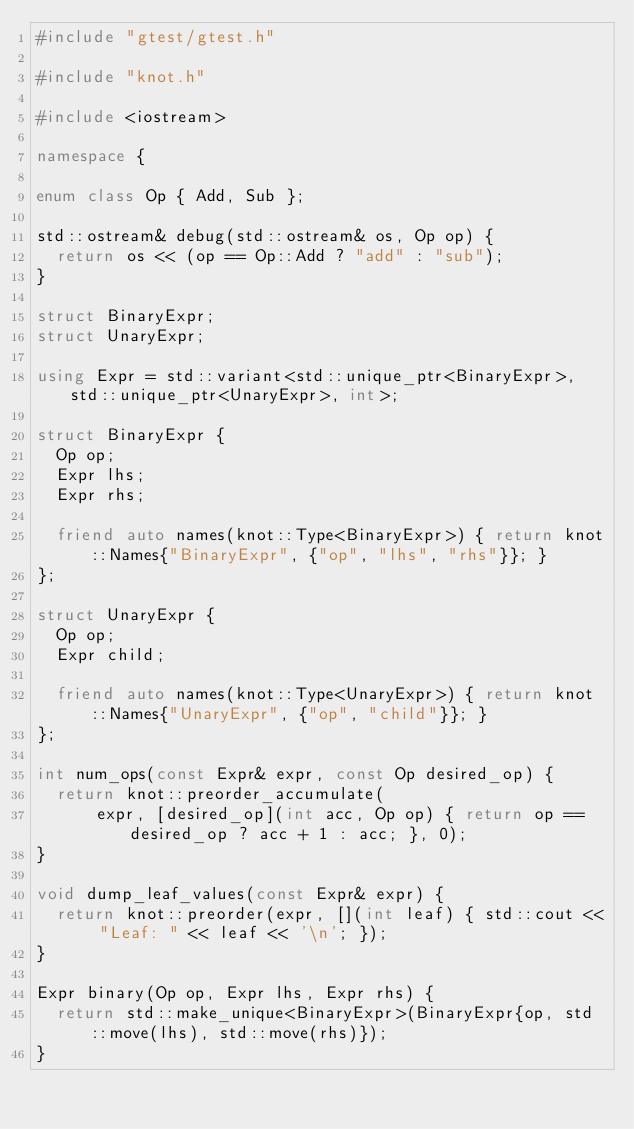<code> <loc_0><loc_0><loc_500><loc_500><_C++_>#include "gtest/gtest.h"

#include "knot.h"

#include <iostream>

namespace {

enum class Op { Add, Sub };

std::ostream& debug(std::ostream& os, Op op) {
  return os << (op == Op::Add ? "add" : "sub");
}

struct BinaryExpr;
struct UnaryExpr;

using Expr = std::variant<std::unique_ptr<BinaryExpr>, std::unique_ptr<UnaryExpr>, int>;

struct BinaryExpr {
  Op op;
  Expr lhs;
  Expr rhs;

  friend auto names(knot::Type<BinaryExpr>) { return knot::Names{"BinaryExpr", {"op", "lhs", "rhs"}}; }
};

struct UnaryExpr {
  Op op;
  Expr child;

  friend auto names(knot::Type<UnaryExpr>) { return knot::Names{"UnaryExpr", {"op", "child"}}; }
};

int num_ops(const Expr& expr, const Op desired_op) {
  return knot::preorder_accumulate(
      expr, [desired_op](int acc, Op op) { return op == desired_op ? acc + 1 : acc; }, 0);
}

void dump_leaf_values(const Expr& expr) {
  return knot::preorder(expr, [](int leaf) { std::cout << "Leaf: " << leaf << '\n'; });
}

Expr binary(Op op, Expr lhs, Expr rhs) {
  return std::make_unique<BinaryExpr>(BinaryExpr{op, std::move(lhs), std::move(rhs)});
}
</code> 